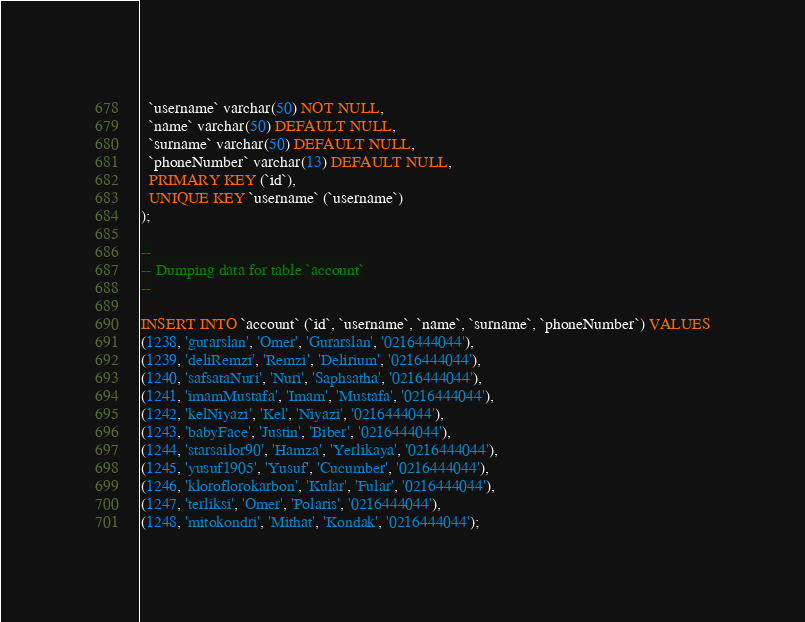<code> <loc_0><loc_0><loc_500><loc_500><_SQL_>  `username` varchar(50) NOT NULL,
  `name` varchar(50) DEFAULT NULL,
  `surname` varchar(50) DEFAULT NULL,
  `phoneNumber` varchar(13) DEFAULT NULL,
  PRIMARY KEY (`id`),
  UNIQUE KEY `username` (`username`)
);

--
-- Dumping data for table `account`
--

INSERT INTO `account` (`id`, `username`, `name`, `surname`, `phoneNumber`) VALUES
(1238, 'gurarslan', 'Omer', 'Gurarslan', '0216444044'),
(1239, 'deliRemzi', 'Remzi', 'Delirium', '0216444044'),
(1240, 'safsataNuri', 'Nuri', 'Saphsatha', '0216444044'),
(1241, 'imamMustafa', 'Imam', 'Mustafa', '0216444044'),
(1242, 'kelNiyazi', 'Kel', 'Niyazi', '0216444044'),
(1243, 'babyFace', 'Justin', 'Biber', '0216444044'),
(1244, 'starsailor90', 'Hamza', 'Yerlikaya', '0216444044'),
(1245, 'yusuf1905', 'Yusuf', 'Cucumber', '0216444044'),
(1246, 'kloroflorokarbon', 'Kular', 'Fular', '0216444044'),
(1247, 'terliksi', 'Omer', 'Polaris', '0216444044'),
(1248, 'mitokondri', 'Mithat', 'Kondak', '0216444044');
</code> 